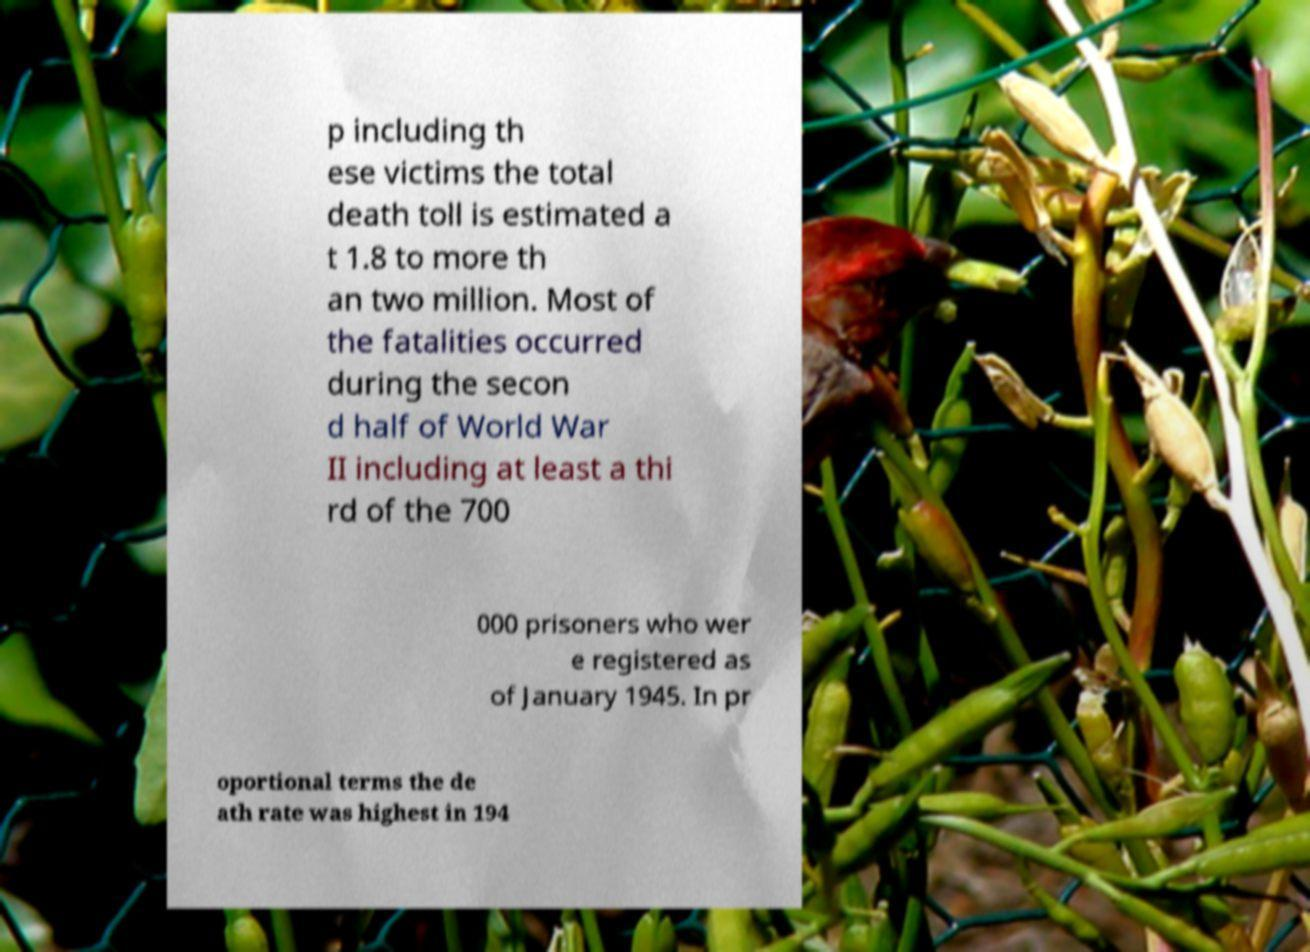Could you extract and type out the text from this image? p including th ese victims the total death toll is estimated a t 1.8 to more th an two million. Most of the fatalities occurred during the secon d half of World War II including at least a thi rd of the 700 000 prisoners who wer e registered as of January 1945. In pr oportional terms the de ath rate was highest in 194 